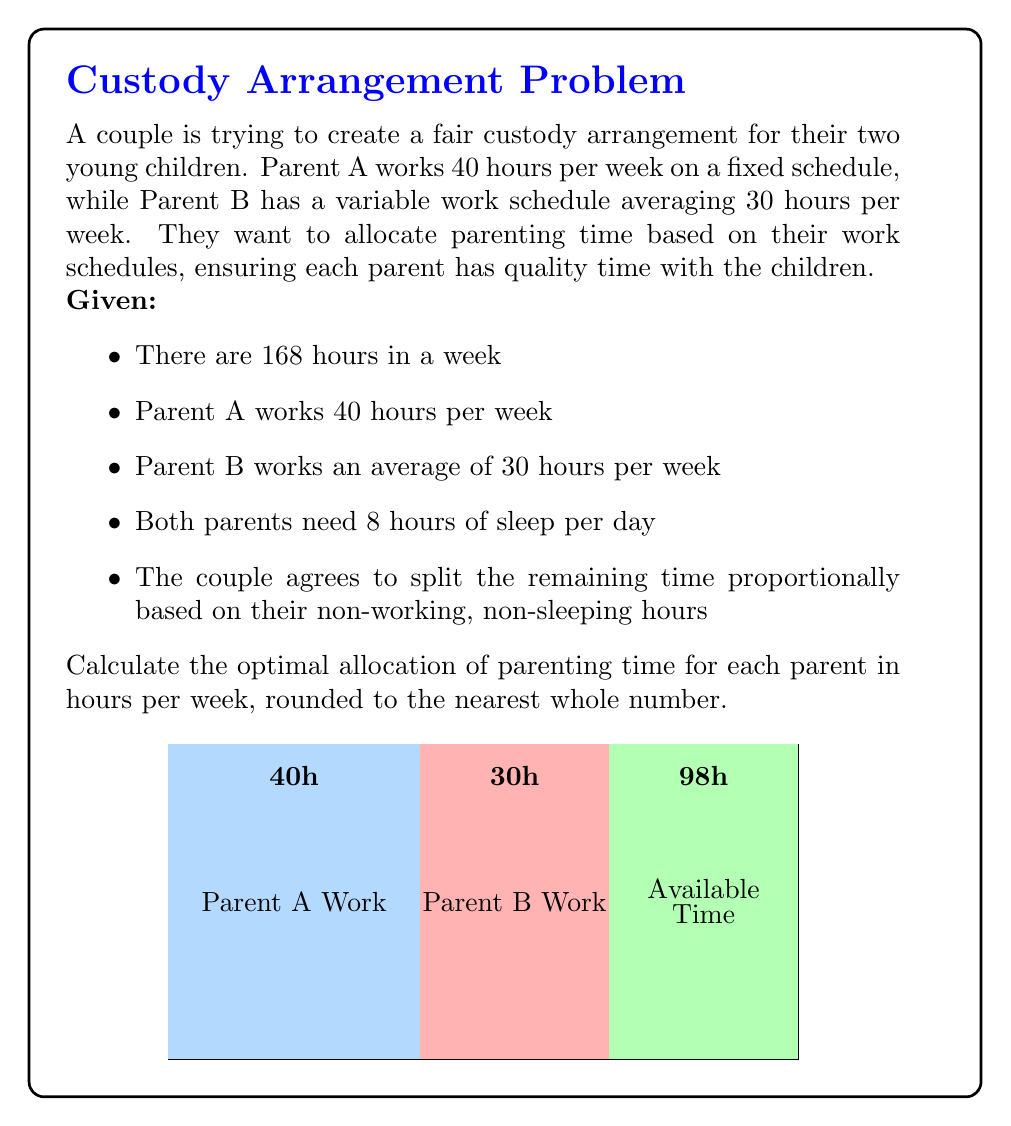Solve this math problem. Let's approach this problem step-by-step:

1) First, calculate the total available time for both parents:
   Total hours per week = 168

2) Calculate sleep time for both parents:
   Sleep time = 8 hours/day * 7 days = 56 hours/week

3) Calculate the remaining time after work and sleep:
   Parent A: 168 - 40 (work) - 56 (sleep) = 72 hours
   Parent B: 168 - 30 (work) - 56 (sleep) = 82 hours

4) Calculate the total available parenting time:
   Total parenting time = 72 + 82 = 154 hours

5) Calculate the proportion of available time for each parent:
   Parent A: $\frac{72}{154} = \frac{36}{77}$
   Parent B: $\frac{82}{154} = \frac{41}{77}$

6) Allocate the total weekly hours (168) based on these proportions:
   Parent A: $168 * \frac{36}{77} \approx 78.5$ hours
   Parent B: $168 * \frac{41}{77} \approx 89.5$ hours

7) Round to the nearest whole number:
   Parent A: 79 hours
   Parent B: 90 hours
Answer: Parent A: 79 hours, Parent B: 90 hours 